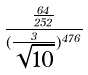<formula> <loc_0><loc_0><loc_500><loc_500>\frac { \frac { 6 4 } { 2 5 2 } } { ( \frac { 3 } { \sqrt { 1 0 } } ) ^ { 4 7 6 } }</formula> 